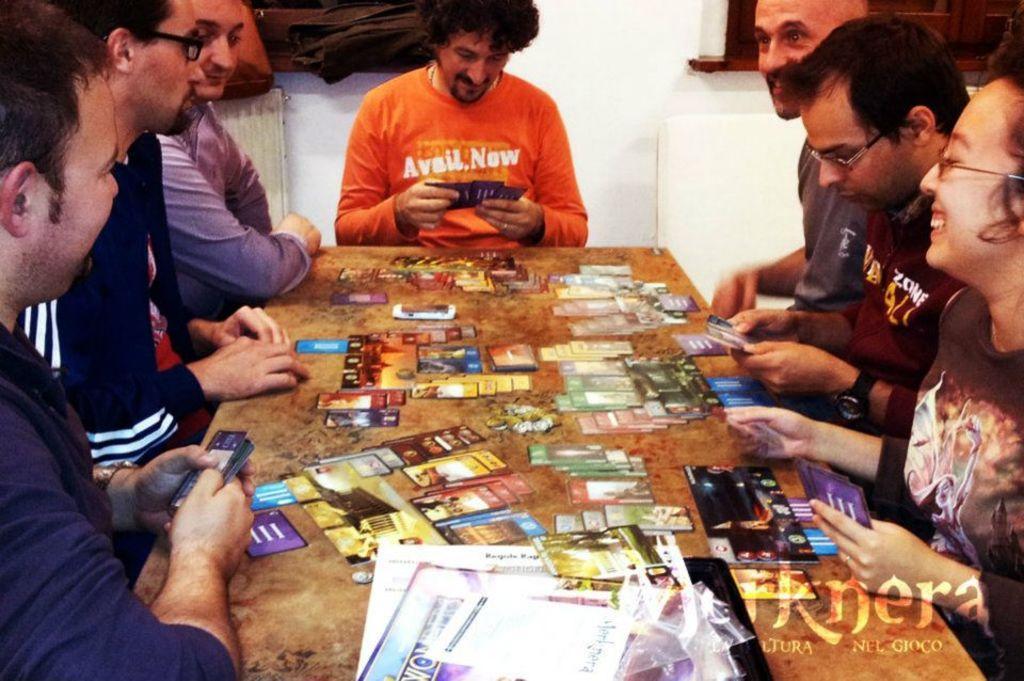Can you describe this image briefly? In this image we can see persons sitting around the table. On the table we can see cards. In the background we can see window and wall. 